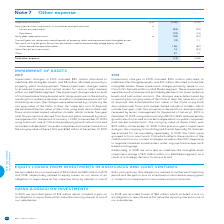According to Bce's financial document, What is the amount of gains (losses) on investments in 2019? According to the financial document, 13 (in millions). The relevant text states: "edge equity settled share-based compensation plans 138 (80)..." Also, What is the Impairment of assets for 2019? According to the financial document, (102) (in millions). The relevant text states: "Impairment of assets 14, 16 (102) (200)..." Also, What are the losses on investment recorded in 2019 and 2018 related to? equity losses on our share of an obligation to repurchase at fair value the minority interest in one of BCE’s joint ventures. The document states: "illion in 2019 and 2018, respectively, related to equity losses on our share of an obligation to repurchase at fair value the minority interest in one..." Also, can you calculate: What is the change in the impairment of assets? Based on the calculation: -102-(-200), the result is 98 (in millions). This is based on the information: "Impairment of assets 14, 16 (102) (200) Impairment of assets 14, 16 (102) (200)..." The key data points involved are: 102, 200. Also, can you calculate: What is the total amount of equity losses from investments in associates and joint ventures in 2019? Based on the calculation: -53+(-19), the result is -72 (in millions). This is based on the information: "FOR THE YEAR ENDED DECEMBER 31 NOTE 2019 2018 Losses on investments (53) (20)..." The key data points involved are: 19, 53. Also, can you calculate: What is the total amount of 'Other' for 2018 and 2019? Based on the calculation: 37+10, the result is 47 (in millions). This is based on the information: "Other 37 10 Other 37 10..." The key data points involved are: 10, 37. 